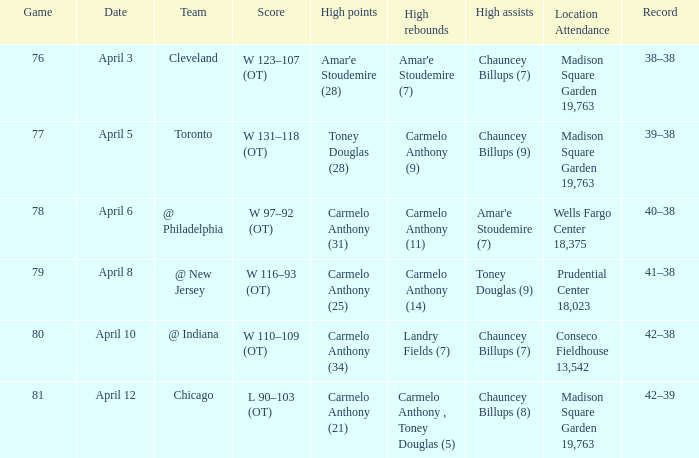Name the high assists for madison square garden 19,763 and record is 39–38 Chauncey Billups (9). 